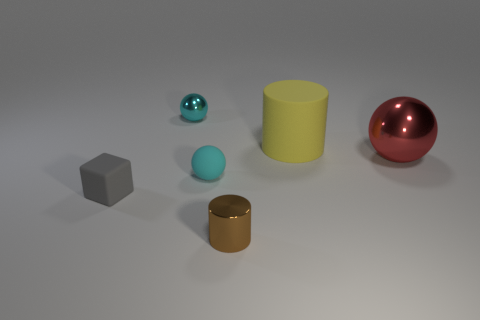Add 3 gray rubber cubes. How many objects exist? 9 Subtract all cylinders. How many objects are left? 4 Add 1 yellow shiny cylinders. How many yellow shiny cylinders exist? 1 Subtract 0 blue balls. How many objects are left? 6 Subtract all tiny red shiny balls. Subtract all tiny shiny objects. How many objects are left? 4 Add 5 gray cubes. How many gray cubes are left? 6 